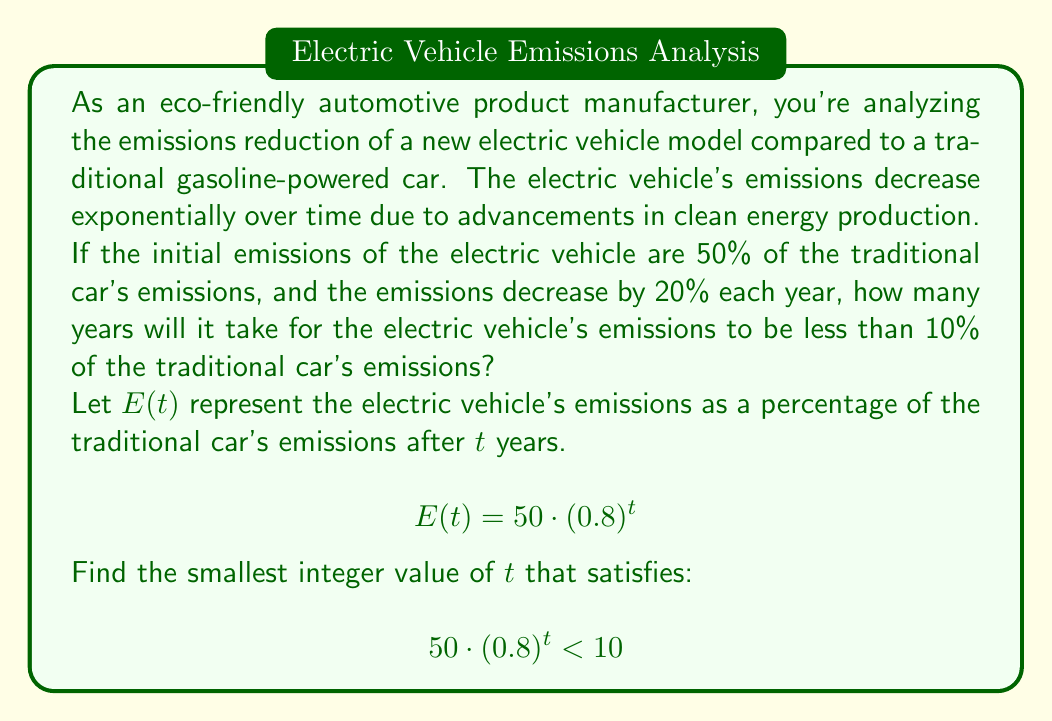Provide a solution to this math problem. To solve this problem, we'll follow these steps:

1) We start with the inequality:
   $$50 \cdot (0.8)^t < 10$$

2) Divide both sides by 50:
   $$(0.8)^t < \frac{10}{50} = 0.2$$

3) Take the natural logarithm of both sides:
   $$\ln((0.8)^t) < \ln(0.2)$$

4) Use the logarithm property $\ln(a^b) = b\ln(a)$:
   $$t \cdot \ln(0.8) < \ln(0.2)$$

5) Divide both sides by $\ln(0.8)$ (note that $\ln(0.8)$ is negative, so the inequality sign flips):
   $$t > \frac{\ln(0.2)}{\ln(0.8)}$$

6) Calculate the right-hand side:
   $$t > \frac{\ln(0.2)}{\ln(0.8)} \approx 7.5424$$

7) Since we need the smallest integer value of $t$, we round up to the next whole number.
Answer: The electric vehicle's emissions will be less than 10% of the traditional car's emissions after 8 years. 